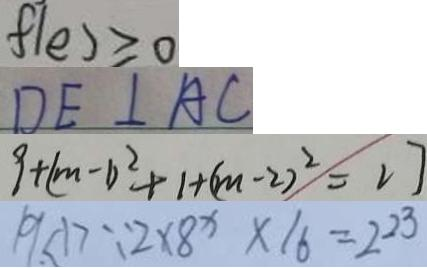<formula> <loc_0><loc_0><loc_500><loc_500>f ( e ) \geq 0 
 D E \bot A C 
 9 + ( m - 1 ) ^ { 2 } + 1 + ( m - 2 ) ^ { 2 } = 2 7 
 1 9 < 1 > \because 2 \times 8 x \times 1 6 = 2 2 3</formula> 